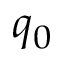Convert formula to latex. <formula><loc_0><loc_0><loc_500><loc_500>q _ { 0 }</formula> 